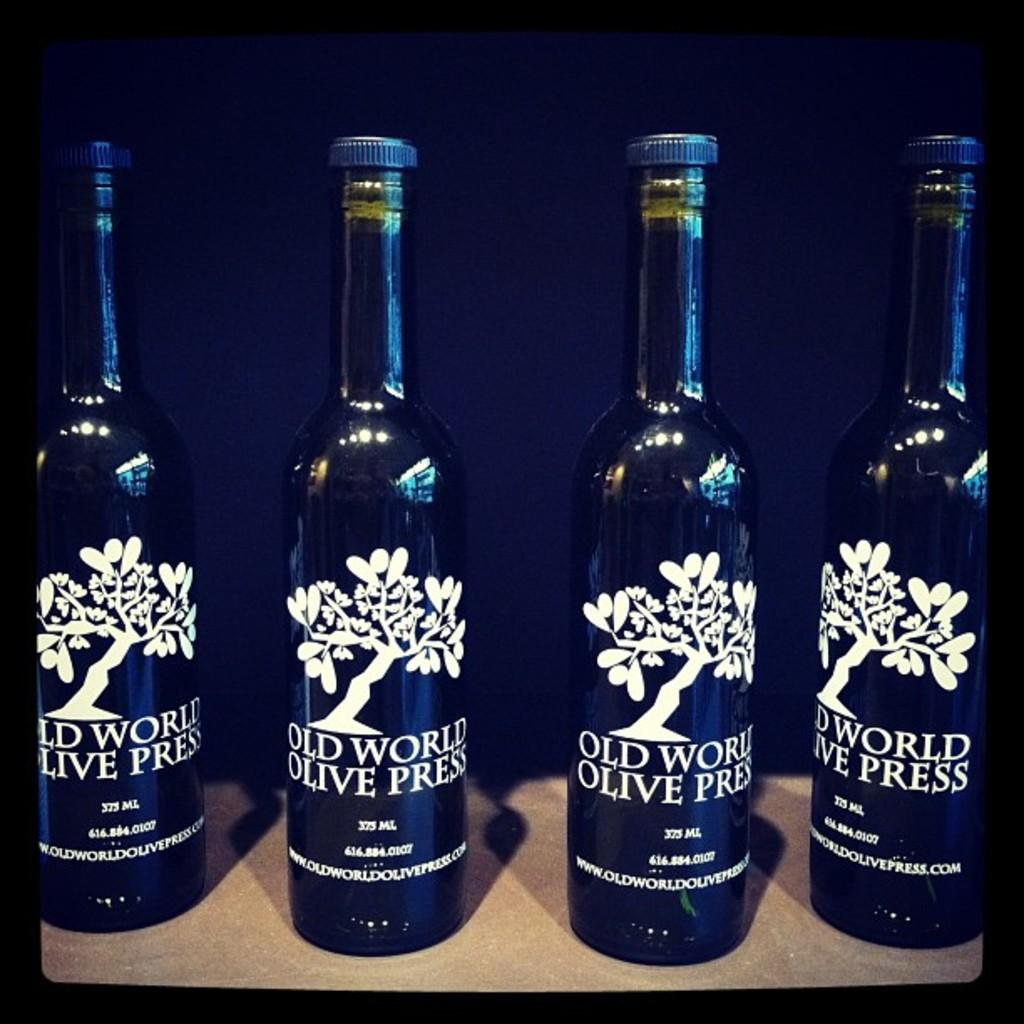<image>
Share a concise interpretation of the image provided. many bottles of Old World Olive Press in blue 